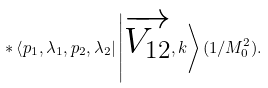<formula> <loc_0><loc_0><loc_500><loc_500>\ast \left \langle p _ { 1 } , \lambda _ { 1 } , p _ { 2 } , \lambda _ { 2 } \right | \left | \overrightarrow { V _ { 1 2 } } , k \right \rangle ( 1 / M _ { 0 } ^ { 2 } ) .</formula> 